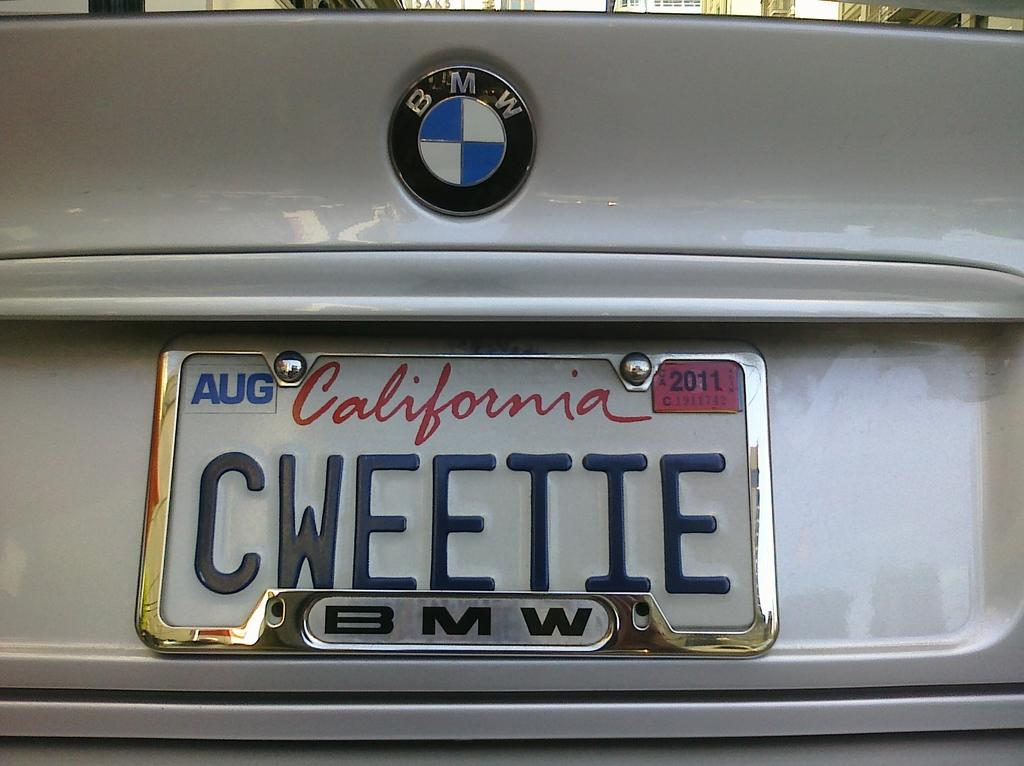<image>
Present a compact description of the photo's key features. A BMW with a California license plate reads "CWEETIE" 